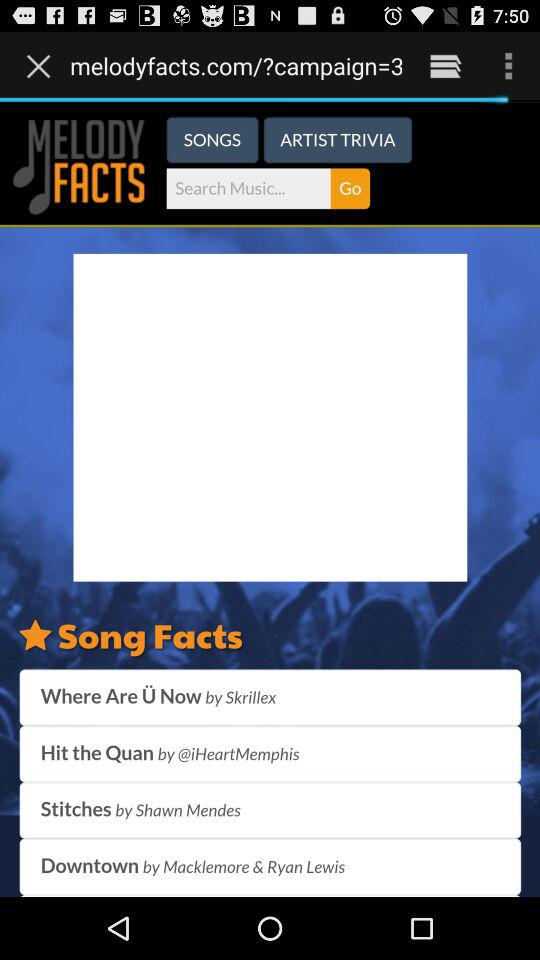Who sang the song "Hit the Quan"? The song "Hit the Quan" was sung by "@iHeartMemphis". 